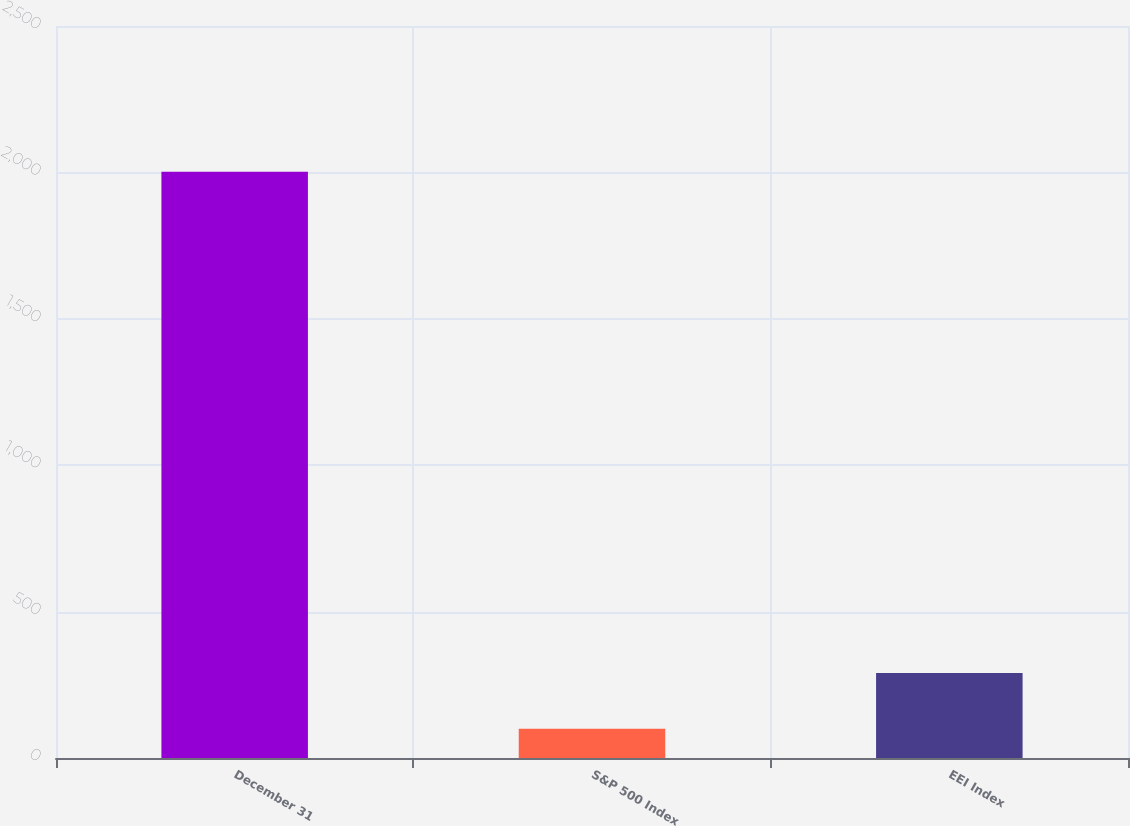Convert chart. <chart><loc_0><loc_0><loc_500><loc_500><bar_chart><fcel>December 31<fcel>S&P 500 Index<fcel>EEI Index<nl><fcel>2002<fcel>100<fcel>290.2<nl></chart> 